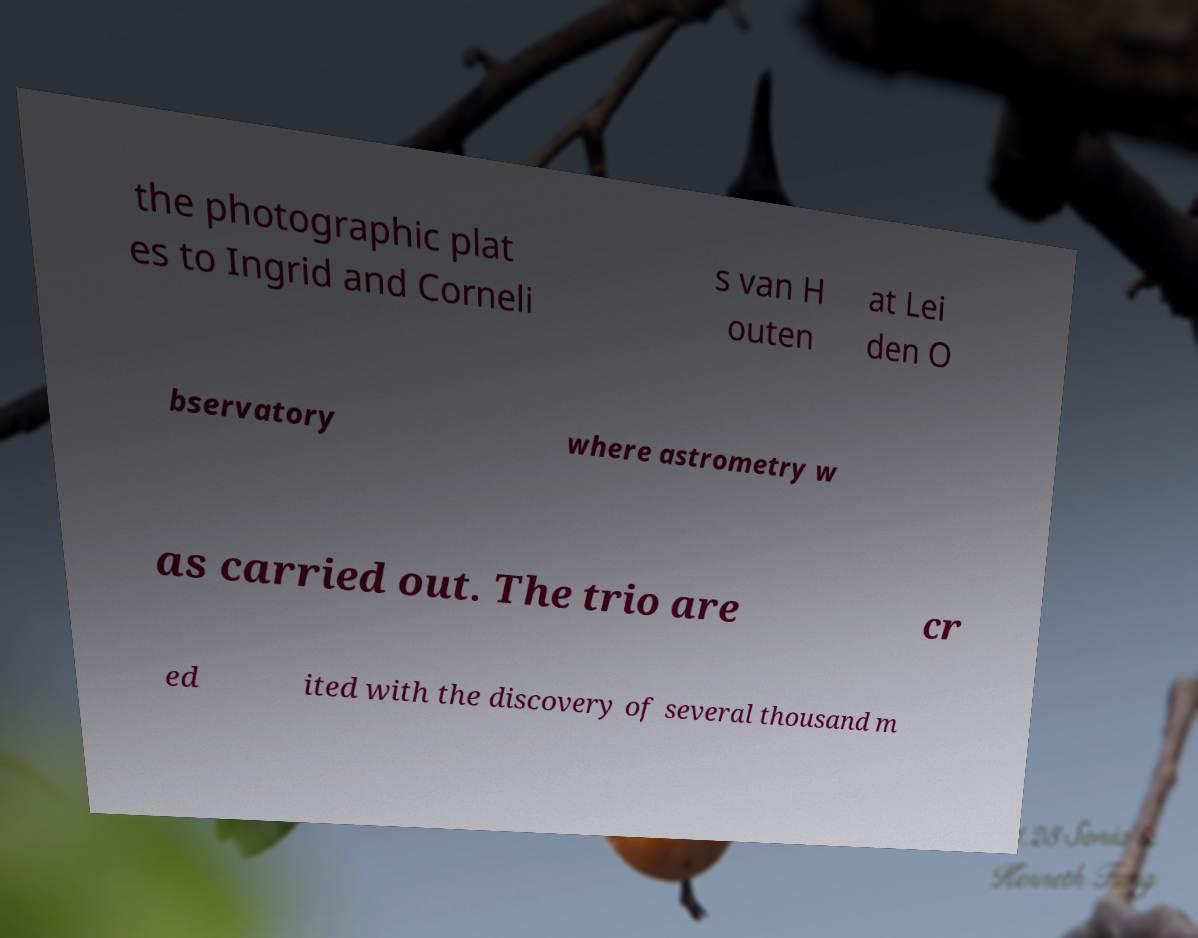Please identify and transcribe the text found in this image. the photographic plat es to Ingrid and Corneli s van H outen at Lei den O bservatory where astrometry w as carried out. The trio are cr ed ited with the discovery of several thousand m 